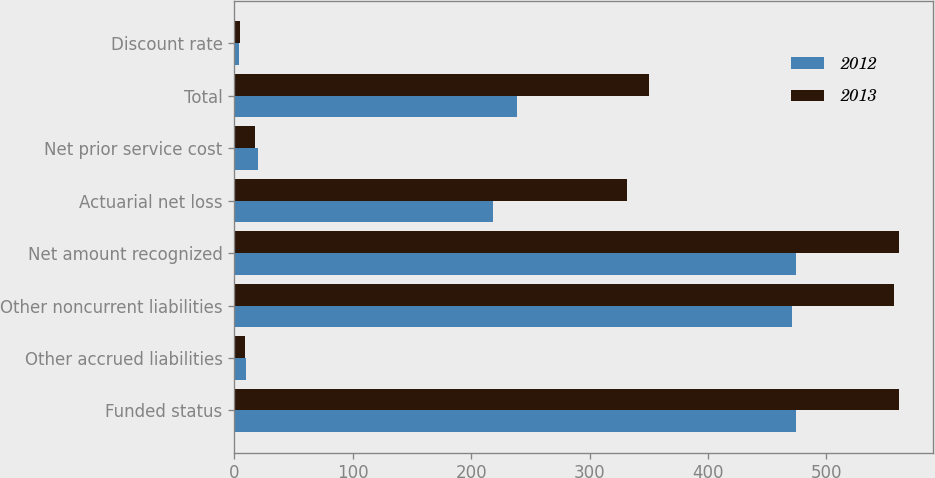Convert chart to OTSL. <chart><loc_0><loc_0><loc_500><loc_500><stacked_bar_chart><ecel><fcel>Funded status<fcel>Other accrued liabilities<fcel>Other noncurrent liabilities<fcel>Net amount recognized<fcel>Actuarial net loss<fcel>Net prior service cost<fcel>Total<fcel>Discount rate<nl><fcel>2012<fcel>474.2<fcel>9.6<fcel>471.2<fcel>474.2<fcel>218.2<fcel>20.3<fcel>238.5<fcel>4.05<nl><fcel>2013<fcel>561.7<fcel>8.8<fcel>556.8<fcel>561.7<fcel>332<fcel>17.9<fcel>349.9<fcel>4.5<nl></chart> 